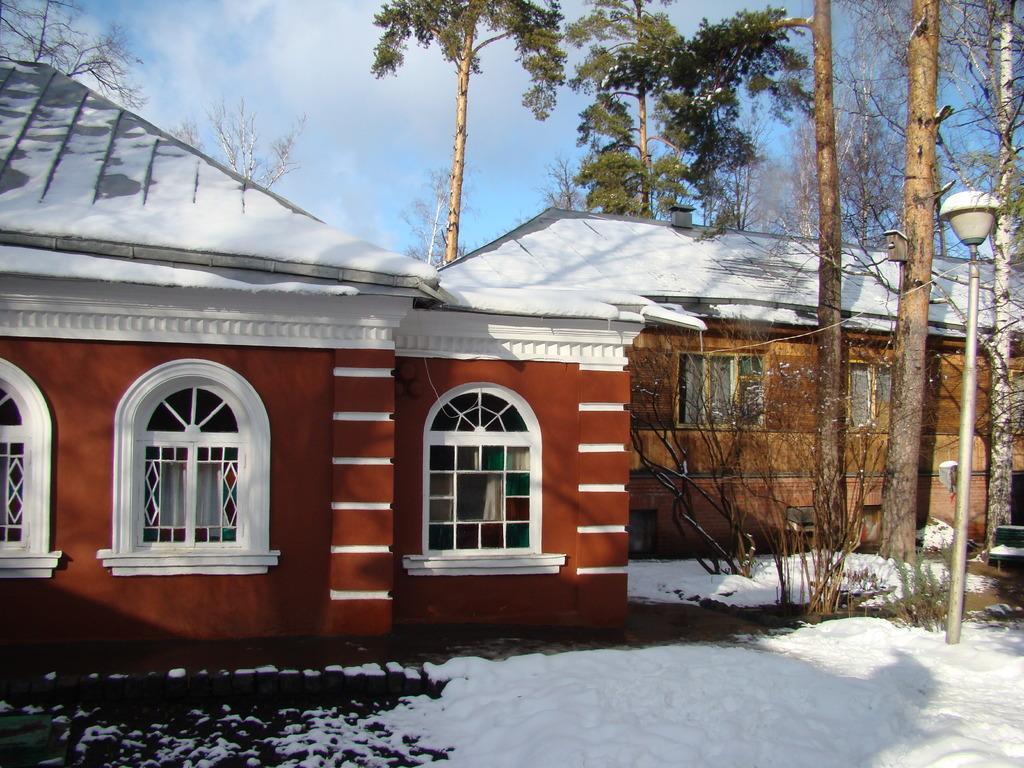Please provide a concise description of this image. There is a building with windows. On the ground there is snow. On the right side there are trees and a light pole. In the background there is sky. 